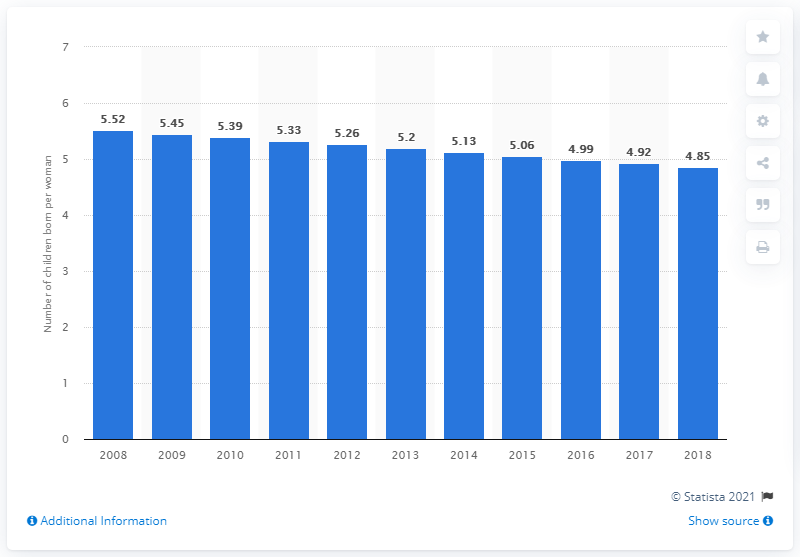Highlight a few significant elements in this photo. In 2018, the fertility rate in Mozambique was 4.85. 